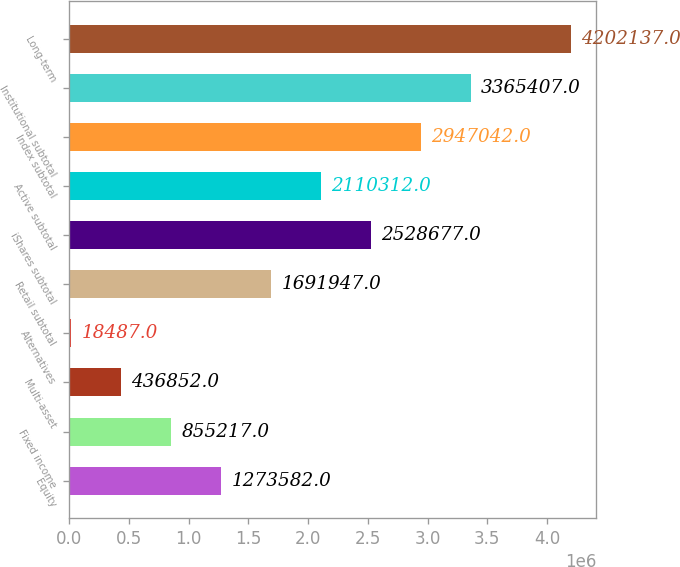Convert chart. <chart><loc_0><loc_0><loc_500><loc_500><bar_chart><fcel>Equity<fcel>Fixed income<fcel>Multi-asset<fcel>Alternatives<fcel>Retail subtotal<fcel>iShares subtotal<fcel>Active subtotal<fcel>Index subtotal<fcel>Institutional subtotal<fcel>Long-term<nl><fcel>1.27358e+06<fcel>855217<fcel>436852<fcel>18487<fcel>1.69195e+06<fcel>2.52868e+06<fcel>2.11031e+06<fcel>2.94704e+06<fcel>3.36541e+06<fcel>4.20214e+06<nl></chart> 